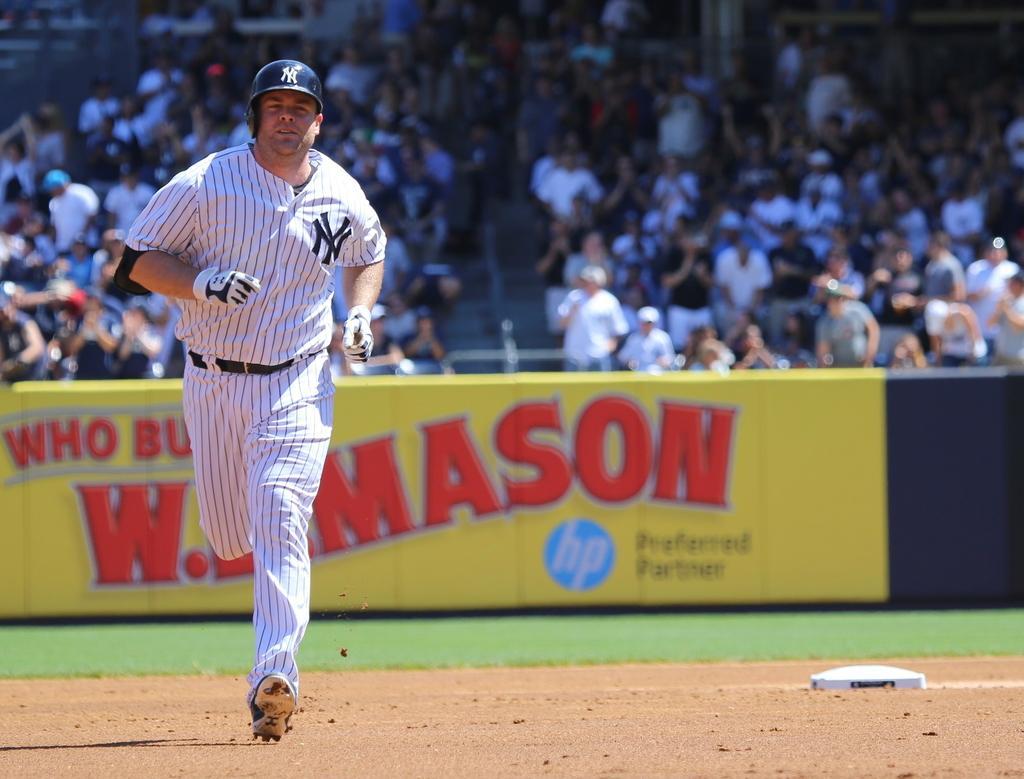How would you summarize this image in a sentence or two? In this image we can see a man running on the ground. He is wearing a sport dress and there is a helmet on his head. In the background, we can see the spectators sitting on the chairs. Here we can see the hoarding. 